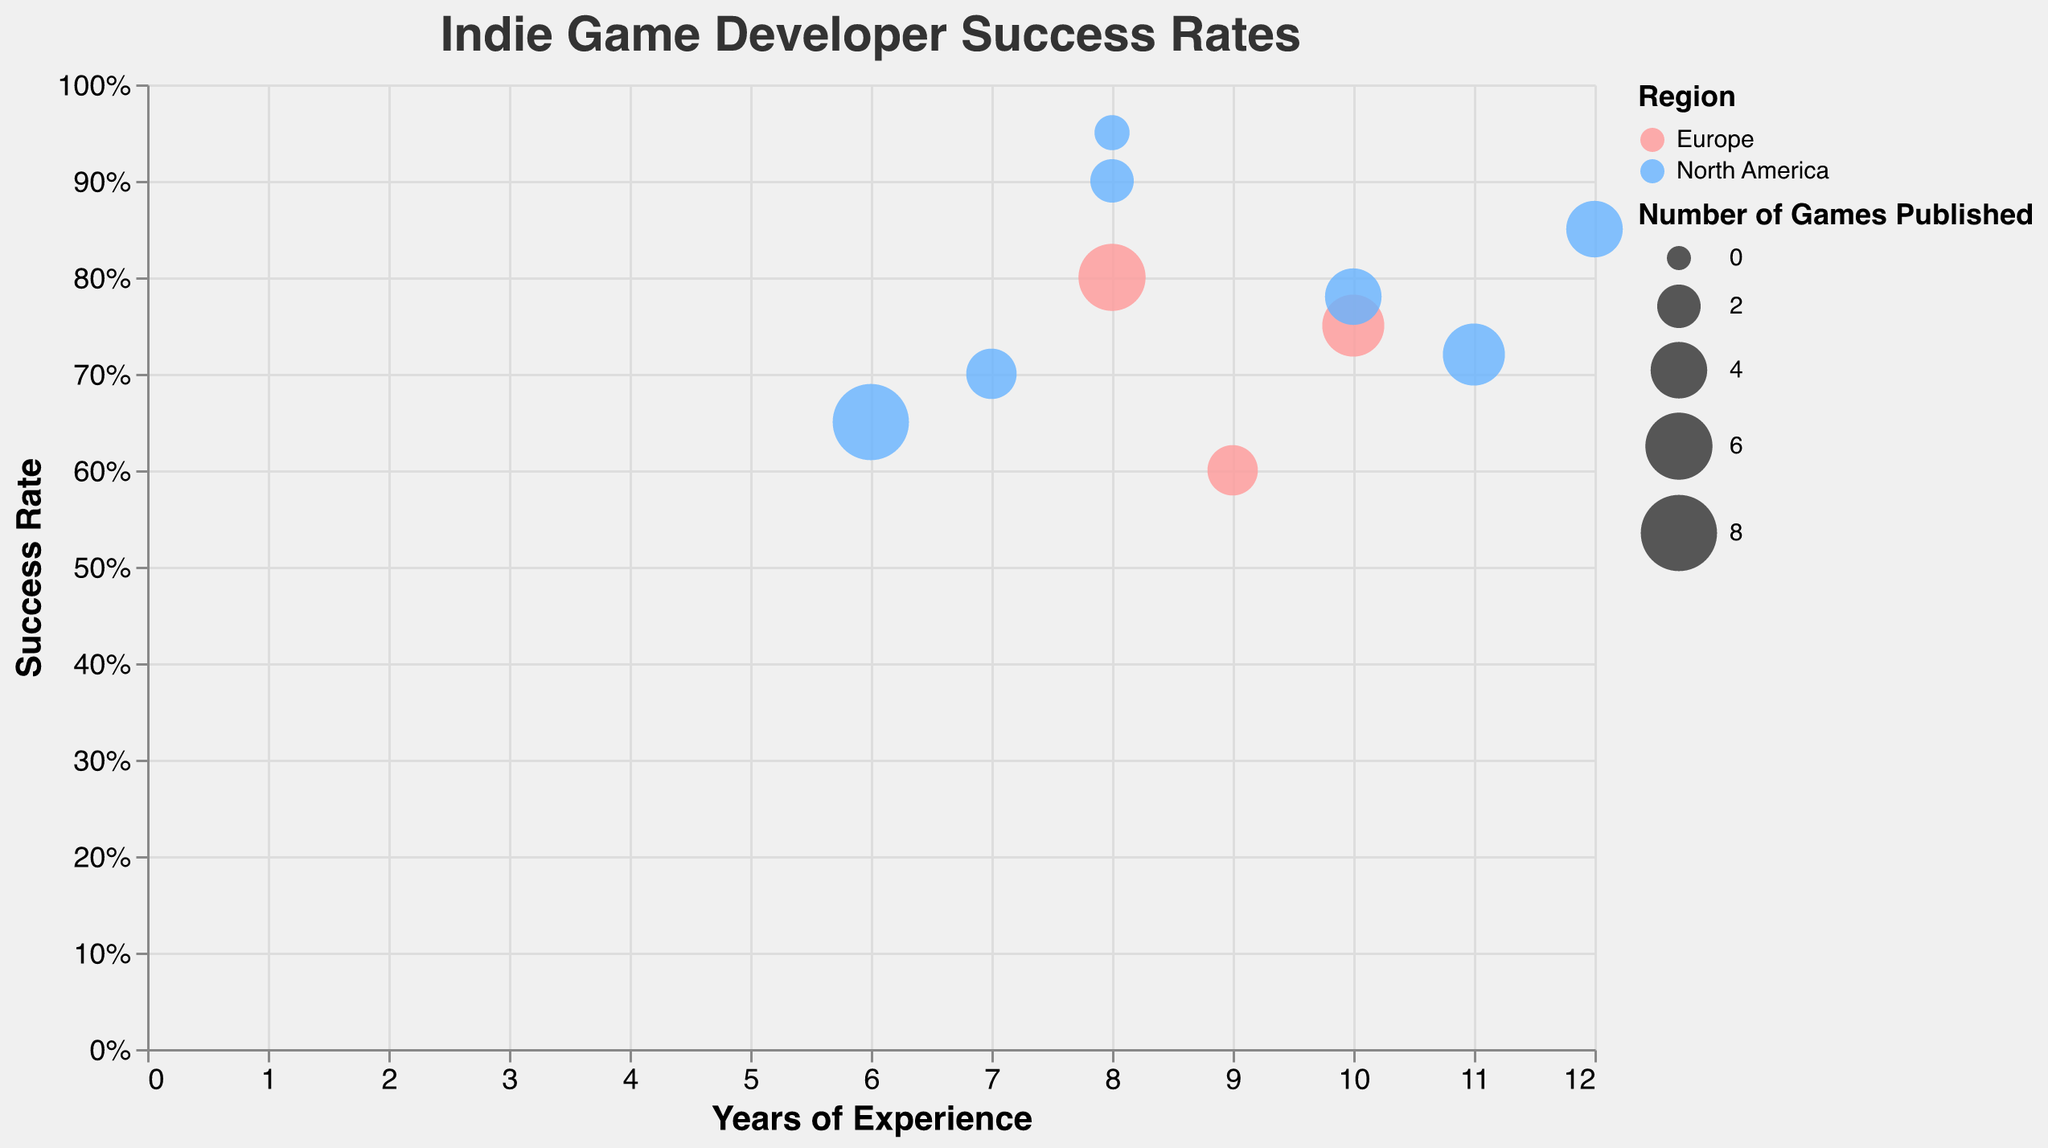How many developers from Europe are represented in the chart? Count the number of developers with the region labeled "Europe". From the data, these are Tom Francis, Arvi Teikari, and Ben Wander.
Answer: 3 Who is the developer with the highest success rate? Look for the highest value in the success rate axis. Eric Barone has the highest success rate of 0.95.
Answer: Eric Barone Which developer has published the most games? Identify the largest circle on the plot since larger size indicates more games published. Angela He, with 8 games published, has the largest circle.
Answer: Angela He What is the relationship between the years of experience and success rate? Observe the general trend in the plot by looking at the x-axis (years of experience) and y-axis (success rate). There is a positive correlation where more years of experience tend to relate to higher success rates.
Answer: Positive correlation What is the average success rate for developers in North America? Identify North American developers (Angela He, Lucas Pope, David Wehle, Toby Fox, Matt Thorson, Eric Barone, Lena Raine) and their success rates (0.65, 0.85, 0.70, 0.90, 0.78, 0.95, 0.72). Calculate the average: (0.65 + 0.85 + 0.70 + 0.90 + 0.78 + 0.95 + 0.72) / 7 = 5.55 / 7.
Answer: 0.79 Who is older, Tom Francis or Lena Raine? Compare the ages of Tom Francis and Lena Raine from the data. Tom Francis is 35, while Lena Raine is 36.
Answer: Lena Raine Which region has more developers, Europe or North America? Count the developers from each region. Europe has 3 (Tom Francis, Arvi Teikari, Ben Wander) and North America has 7 (Angela He, Lucas Pope, David Wehle, Toby Fox, Matt Thorson, Eric Barone, Lena Raine).
Answer: North America What is the success rate of a developer with 8 years of experience in Europe? Locate a European developer with 8 years of experience. Arvi Teikari has 8 years of experience and a success rate of 0.80.
Answer: 0.80 How many developers have a success rate of 0.75 or higher? Count how many developers have success rates equal to or greater than 0.75. These developers are Tom Francis, Arvi Teikari, Lucas Pope, Toby Fox, Matt Thorson, Eric Barone, Lena Raine.
Answer: 7 